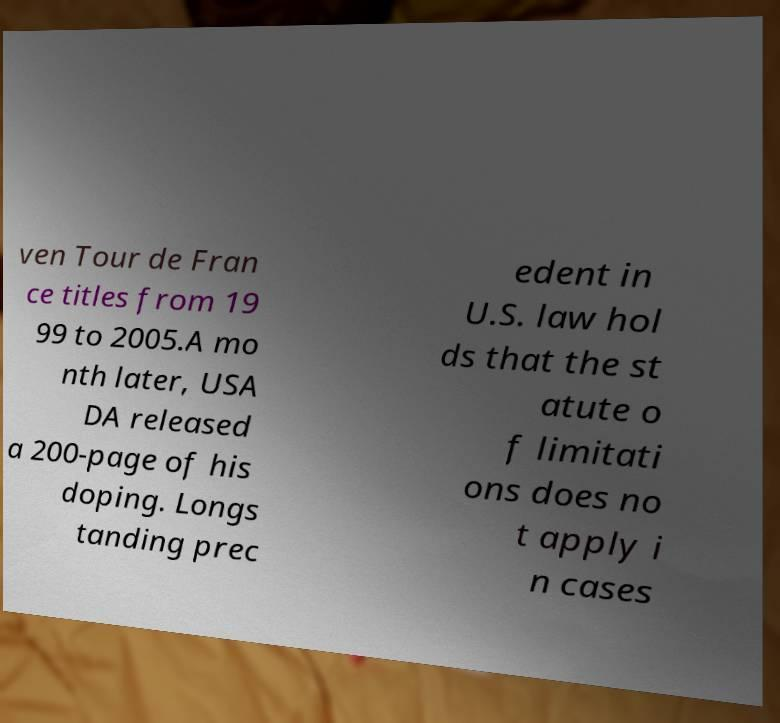Can you accurately transcribe the text from the provided image for me? ven Tour de Fran ce titles from 19 99 to 2005.A mo nth later, USA DA released a 200-page of his doping. Longs tanding prec edent in U.S. law hol ds that the st atute o f limitati ons does no t apply i n cases 